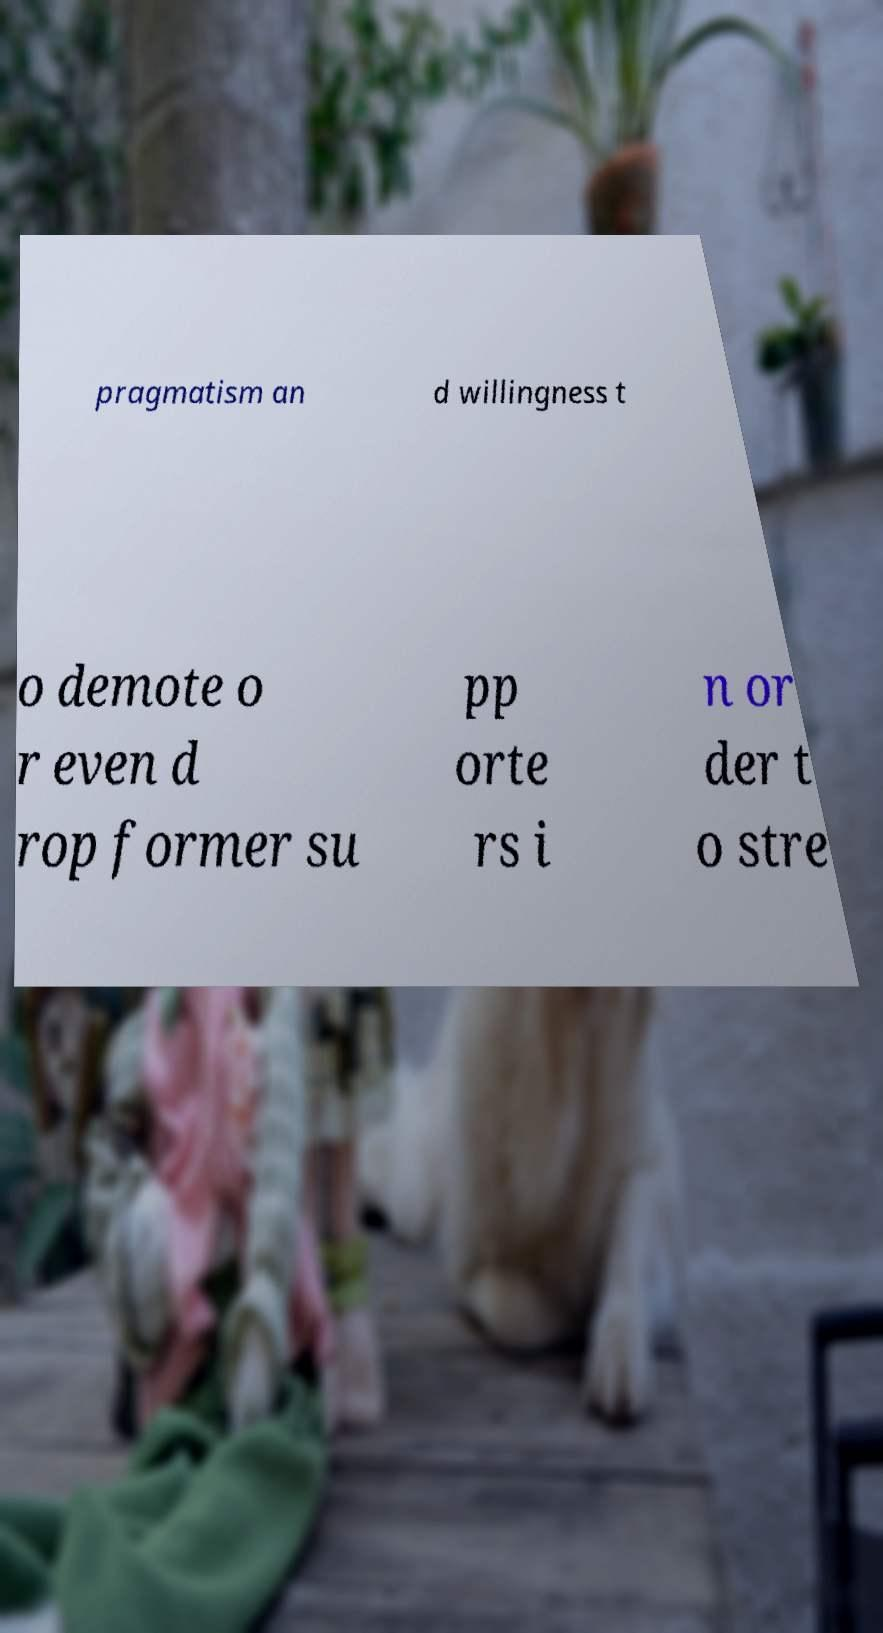What messages or text are displayed in this image? I need them in a readable, typed format. pragmatism an d willingness t o demote o r even d rop former su pp orte rs i n or der t o stre 